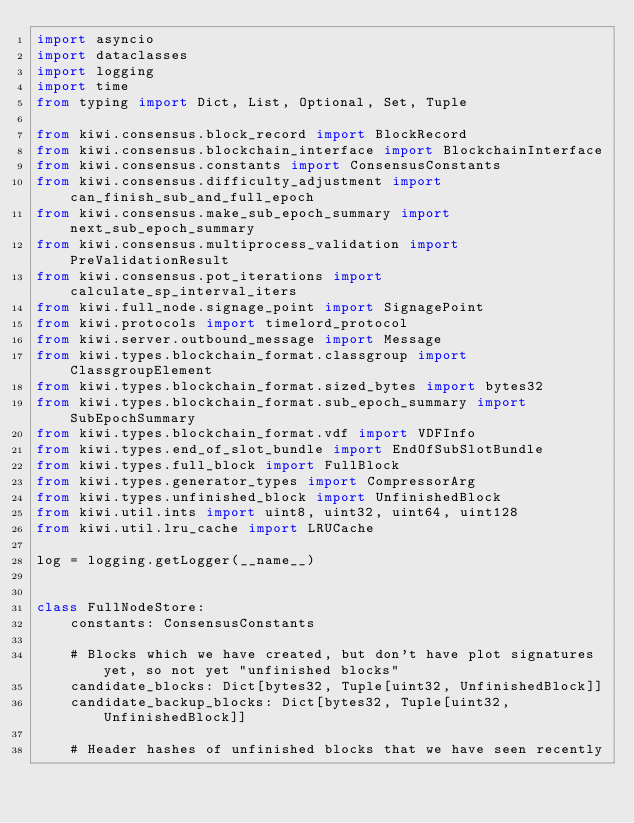<code> <loc_0><loc_0><loc_500><loc_500><_Python_>import asyncio
import dataclasses
import logging
import time
from typing import Dict, List, Optional, Set, Tuple

from kiwi.consensus.block_record import BlockRecord
from kiwi.consensus.blockchain_interface import BlockchainInterface
from kiwi.consensus.constants import ConsensusConstants
from kiwi.consensus.difficulty_adjustment import can_finish_sub_and_full_epoch
from kiwi.consensus.make_sub_epoch_summary import next_sub_epoch_summary
from kiwi.consensus.multiprocess_validation import PreValidationResult
from kiwi.consensus.pot_iterations import calculate_sp_interval_iters
from kiwi.full_node.signage_point import SignagePoint
from kiwi.protocols import timelord_protocol
from kiwi.server.outbound_message import Message
from kiwi.types.blockchain_format.classgroup import ClassgroupElement
from kiwi.types.blockchain_format.sized_bytes import bytes32
from kiwi.types.blockchain_format.sub_epoch_summary import SubEpochSummary
from kiwi.types.blockchain_format.vdf import VDFInfo
from kiwi.types.end_of_slot_bundle import EndOfSubSlotBundle
from kiwi.types.full_block import FullBlock
from kiwi.types.generator_types import CompressorArg
from kiwi.types.unfinished_block import UnfinishedBlock
from kiwi.util.ints import uint8, uint32, uint64, uint128
from kiwi.util.lru_cache import LRUCache

log = logging.getLogger(__name__)


class FullNodeStore:
    constants: ConsensusConstants

    # Blocks which we have created, but don't have plot signatures yet, so not yet "unfinished blocks"
    candidate_blocks: Dict[bytes32, Tuple[uint32, UnfinishedBlock]]
    candidate_backup_blocks: Dict[bytes32, Tuple[uint32, UnfinishedBlock]]

    # Header hashes of unfinished blocks that we have seen recently</code> 